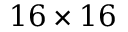Convert formula to latex. <formula><loc_0><loc_0><loc_500><loc_500>1 6 \times 1 6</formula> 